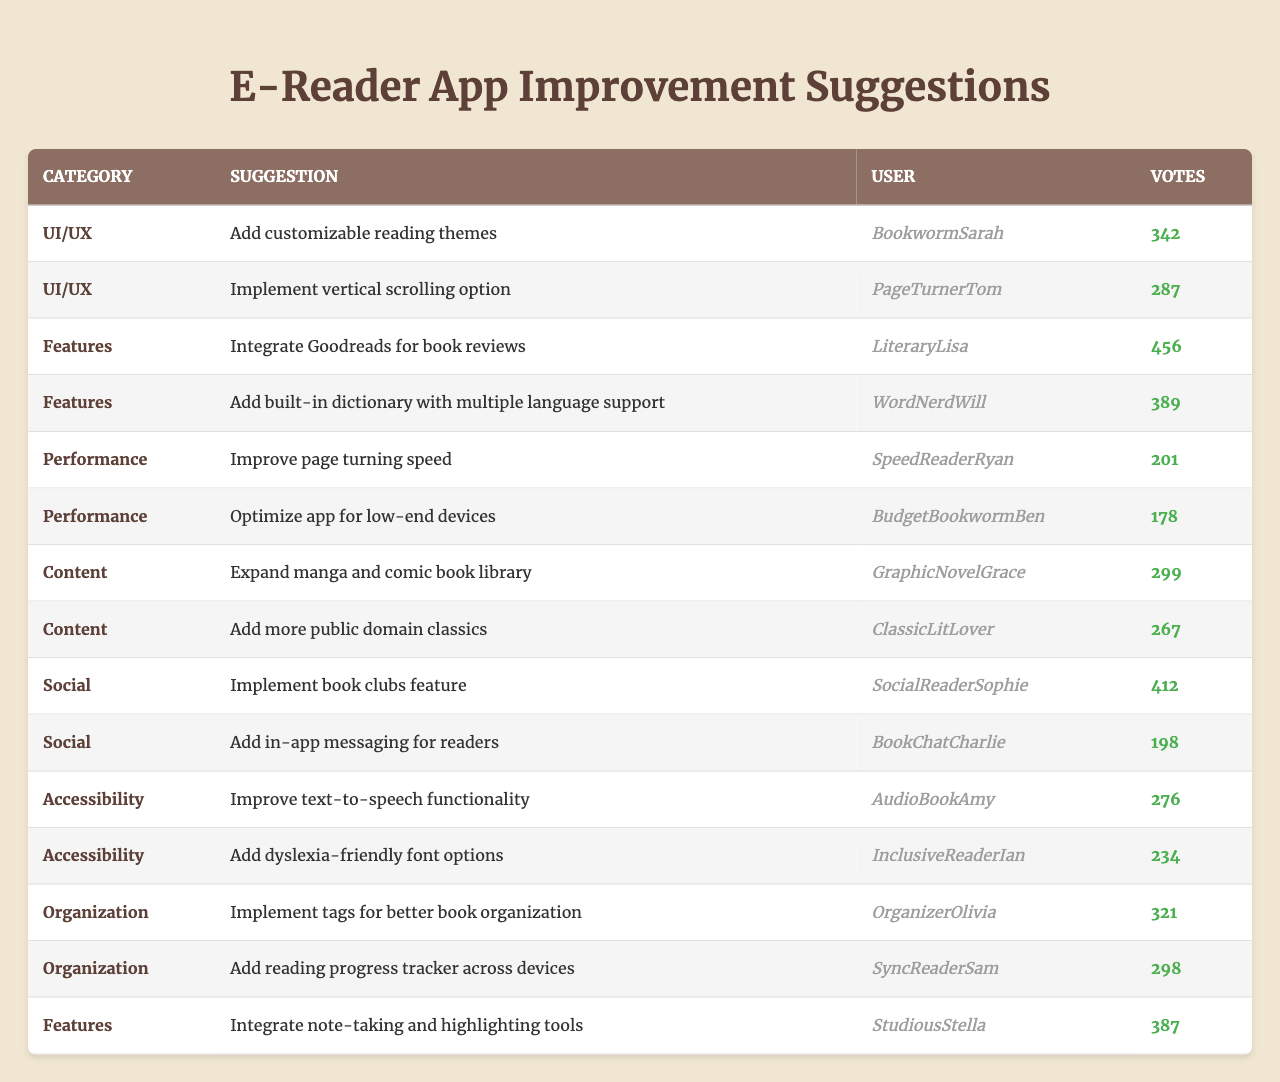What is the suggestion with the highest number of votes? The table lists several suggestions along with their respective votes. By comparing the votes, "Integrate Goodreads for book reviews" has the highest votes at 456.
Answer: 456 Which category has the least number of suggestions listed? By examining the table categories, "Performance" has only two suggestions compared to other categories which have more.
Answer: Performance How many votes did the suggestion "Add more public domain classics" receive? The table lists the votes for each suggestion, and "Add more public domain classics" received 267 votes.
Answer: 267 What is the total number of votes for suggestions in the "UI/UX" category? The votes for "Add customizable reading themes" (342) and "Implement vertical scrolling option" (287) add up to 629 votes for the UI/UX category.
Answer: 629 True or False: The suggestion "Add in-app messaging for readers" received more votes than "Improve text-to-speech functionality." "Add in-app messaging for readers" received 198 votes, while "Improve text-to-speech functionality" received 276 votes, making this statement false.
Answer: False Which user has submitted the suggestion with the second highest votes? "LiteraryLisa" submitted "Integrate Goodreads for book reviews," which has the highest votes at 456, so the next highest is "StudiousStella" with 387 votes for "Integrate note-taking and highlighting tools."
Answer: StudiousStella What is the average number of votes for suggestions under the "Features" category? The votes for "Features" are 456, 389, and 387. Summing these gives 1232 votes. Dividing by the number of suggestions (3) gives an average of 410.67 votes.
Answer: 410.67 How many users have submitted suggestions related to "Content"? Two suggestions in the "Content" category, made by two users: "GraphicNovelGrace" and "ClassicLitLover." Hence, there are 2 users.
Answer: 2 Which suggestion received more votes: "Improve page turning speed" or "Optimize app for low-end devices"? "Improve page turning speed" received 201 votes while "Optimize app for low-end devices" received 178 votes. Therefore, the first received more.
Answer: Improve page turning speed What is the collective vote count for all suggestions in the "Social" category? The votes for the "Social" category are 412 and 198. Adding these together gives a total of 610 votes.
Answer: 610 